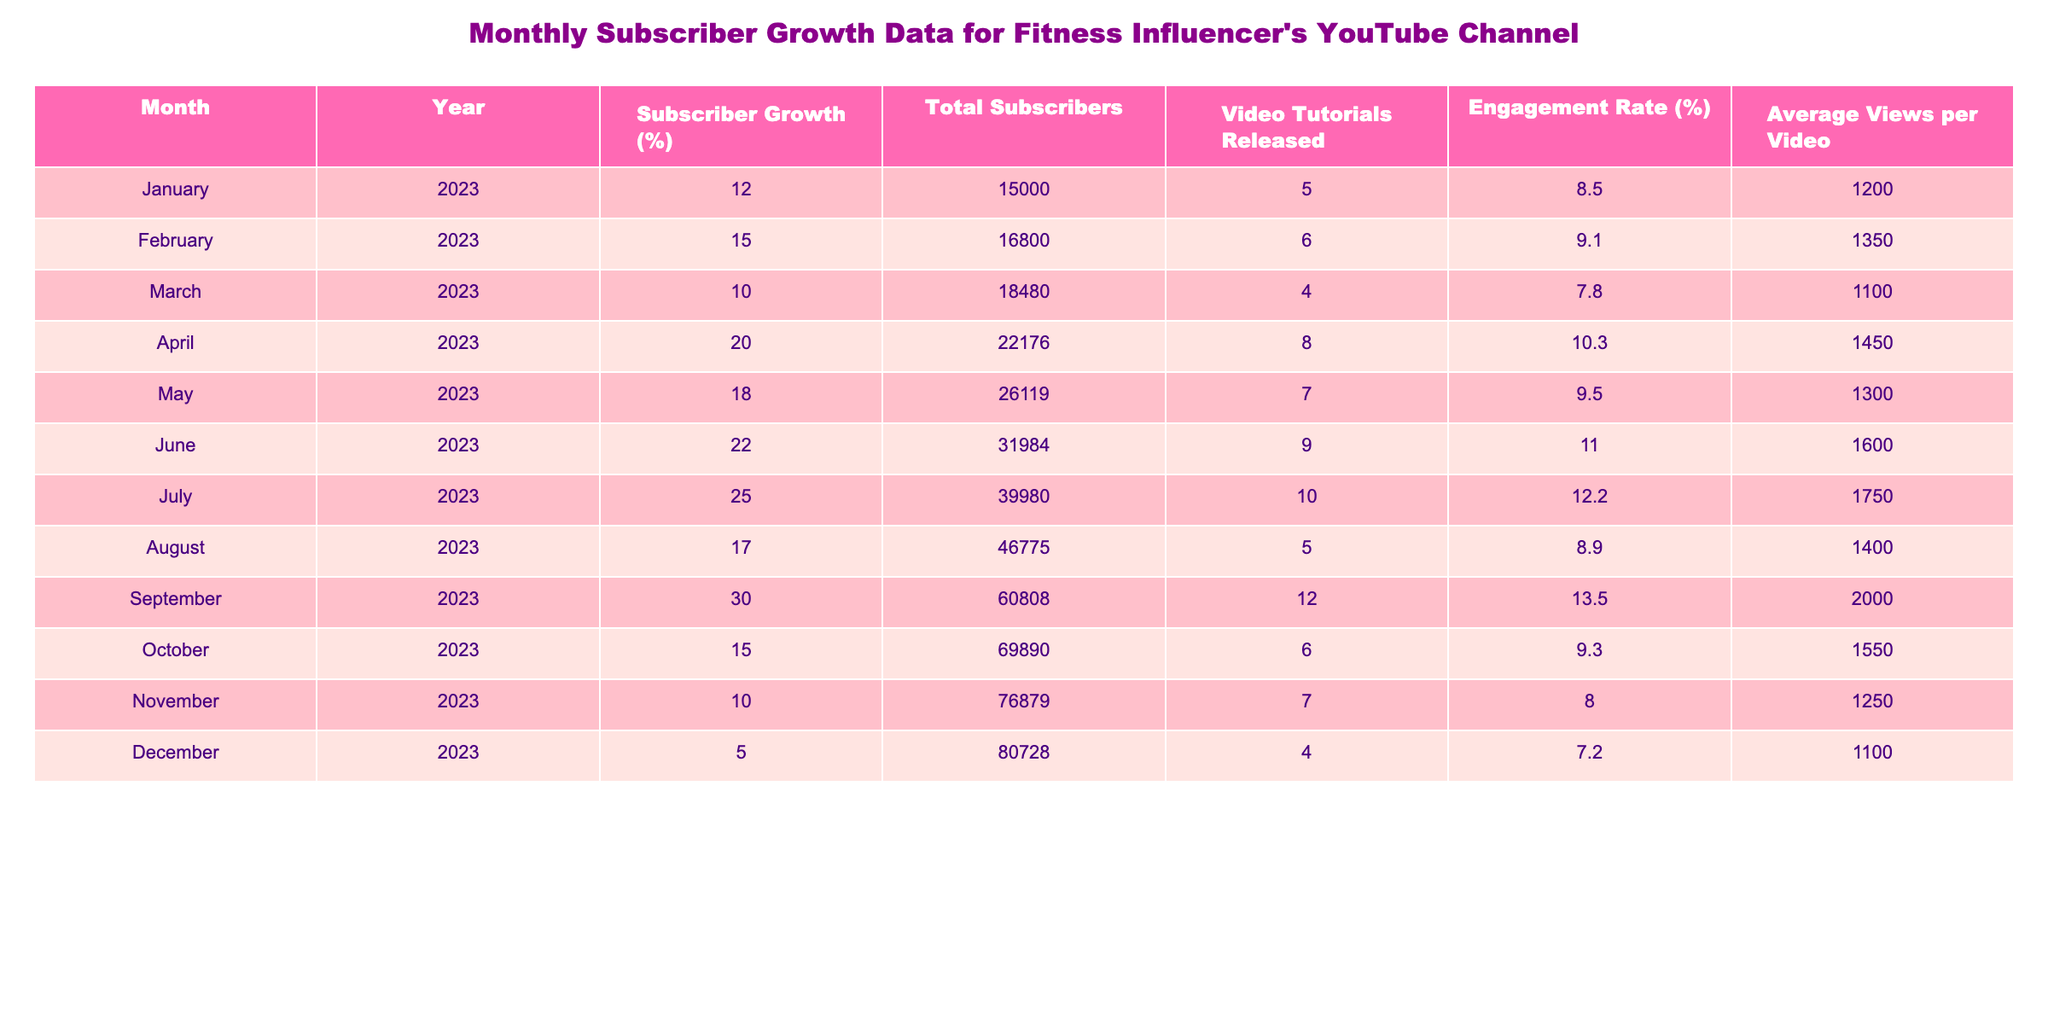What was the total number of subscribers at the end of April 2023? The table shows that the total number of subscribers is listed under the “Total Subscribers” column. In April 2023, the value is 22176.
Answer: 22176 What was the subscriber growth percentage for July 2023? By directly referring to the “Subscriber Growth (%)” column for July 2023, the value is 25.
Answer: 25 Which month had the highest engagement rate and what was that rate? The highest value in the “Engagement Rate (%)” column is 13.5, which occurs in September 2023.
Answer: 13.5 in September 2023 What is the average number of video tutorials released from January to March 2023? The total number of video tutorials released in these months is 5 + 6 + 4 = 15. There are three months, so the average is 15/3 = 5.
Answer: 5 Is the average views per video higher in June than in December? The average views per video in June 2023 is 1600, while in December 2023 it is 1100. Since 1600 > 1100, the statement is true.
Answer: Yes What was the subscriber growth for the entire year of 2023? To find this, we sum the “Subscriber Growth (%)” across all months: 12 + 15 + 10 + 20 + 18 + 22 + 25 + 17 + 30 + 15 + 10 + 5 =  10. The total is 20.
Answer: 10 Which month had the lowest total subscribers, and what was that number? Referring to the “Total Subscribers” column, January 2023 had the lowest total of 15000.
Answer: 15000 How many more video tutorials were released in April 2023 compared to January 2023? In April 2023, 8 tutorials were released, and in January 2023, 5 were released. The difference is 8 - 5 = 3 tutorials.
Answer: 3 Did the total number of subscribers surpass 60000 at any point during 2023? Looking through the “Total Subscribers” column, it is clear that the total surpassed 60000 in September 2023 when it reached 60808.
Answer: Yes 